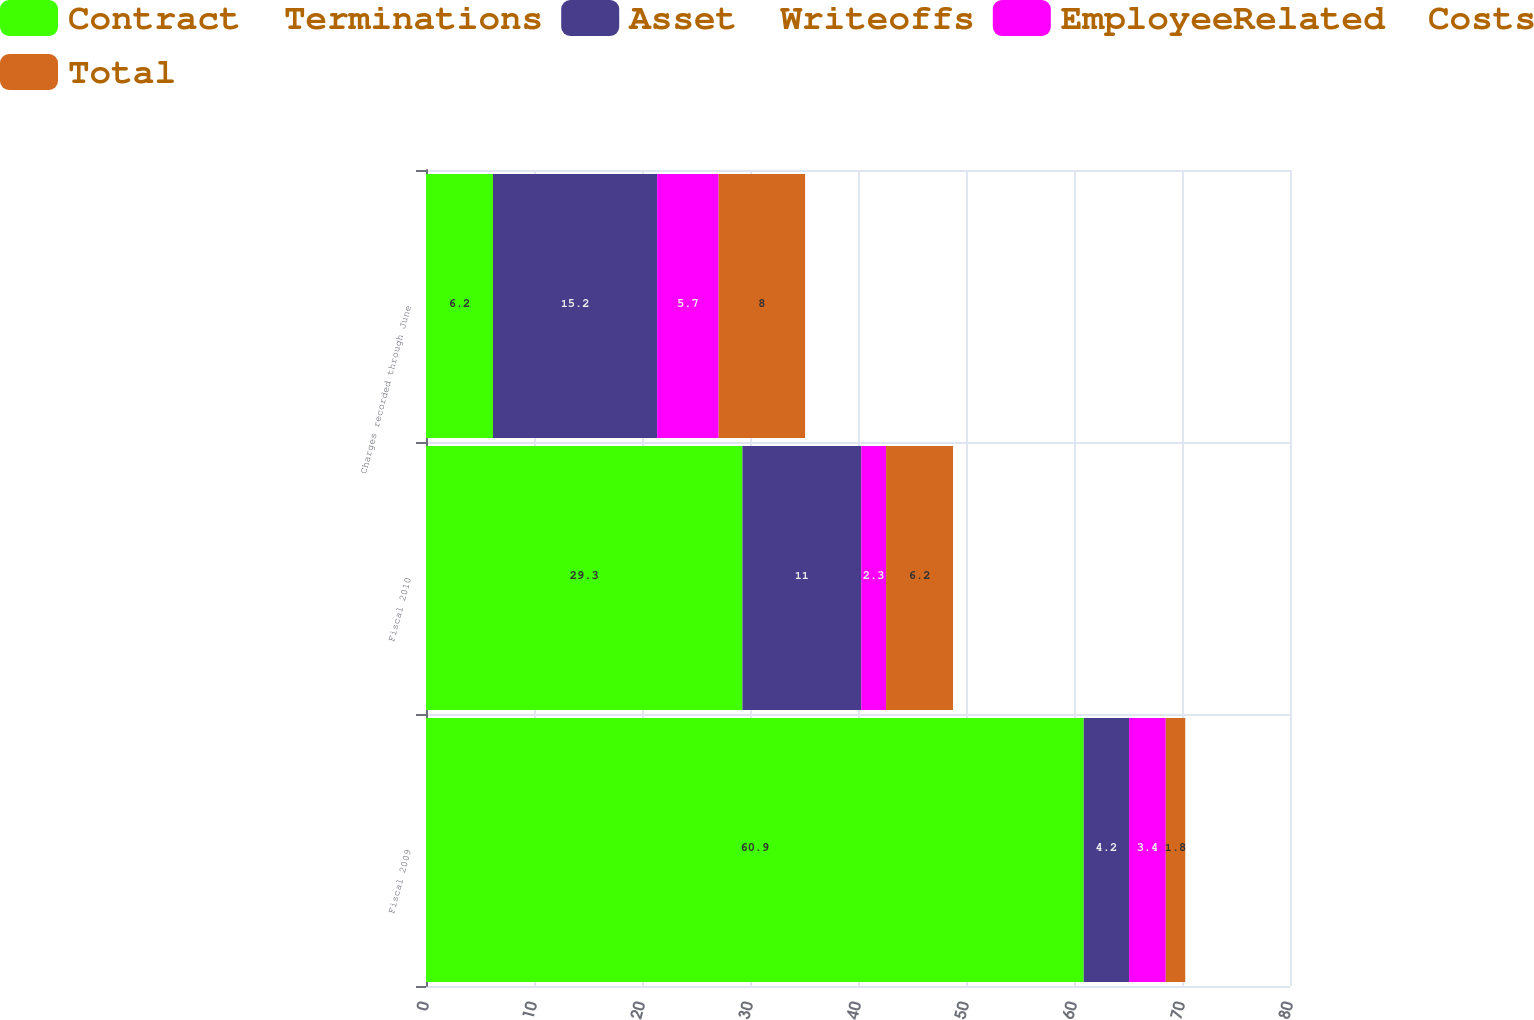Convert chart to OTSL. <chart><loc_0><loc_0><loc_500><loc_500><stacked_bar_chart><ecel><fcel>Fiscal 2009<fcel>Fiscal 2010<fcel>Charges recorded through June<nl><fcel>Contract  Terminations<fcel>60.9<fcel>29.3<fcel>6.2<nl><fcel>Asset  Writeoffs<fcel>4.2<fcel>11<fcel>15.2<nl><fcel>EmployeeRelated  Costs<fcel>3.4<fcel>2.3<fcel>5.7<nl><fcel>Total<fcel>1.8<fcel>6.2<fcel>8<nl></chart> 